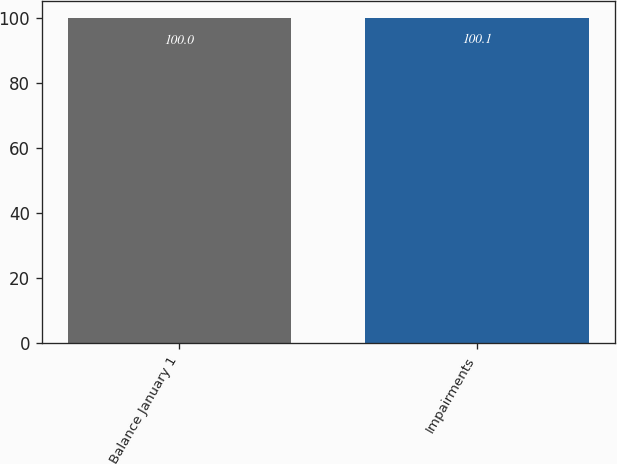Convert chart to OTSL. <chart><loc_0><loc_0><loc_500><loc_500><bar_chart><fcel>Balance January 1<fcel>Impairments<nl><fcel>100<fcel>100.1<nl></chart> 